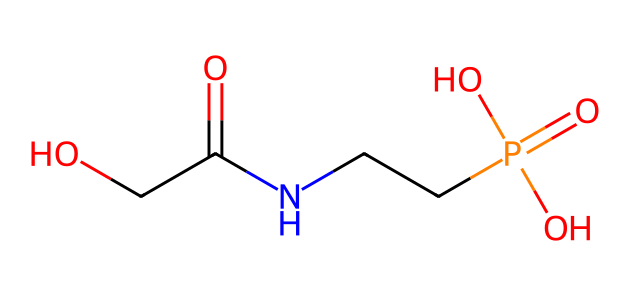What is the molecular formula of glyphosate? To determine the molecular formula, count the different atoms present in the SMILES: there are 3 carbon atoms (C), 8 hydrogen atoms (H), 1 nitrogen atom (N), and 4 oxygen atoms (O). Thus, the molecular formula is C3H8N1O4.
Answer: C3H8N1O4 How many oxygen atoms are in glyphosate? From the SMILES representation, we can see there are 4 oxygen (O) symbols. Counting the total number of oxygen atoms gives us the answer.
Answer: 4 What type of functional group is present in glyphosate? Looking at the structure, the presence of the -COOH (carboxylic acid) and -PO3 (phosphate) groups indicates that glyphosate contains a carboxylic acid and phosphate functional group.
Answer: carboxylic acid and phosphate Which atom in glyphosate is likely responsible for its herbicidal activity? The nitrogen (N) atom in the structure suggests it plays a significant role in glyphosate's mechanism of action, as many herbicides target metabolic pathways involving nitrogen.
Answer: nitrogen What is the total number of carbon-carbon bonds in glyphosate? By examining the structure through the SMILES, we observe that there are no C-C single or double bonds present directly. Since the carbon atoms are connected via other atoms (like nitrogen or oxygen), the total number of carbon-carbon bonds is zero.
Answer: 0 How many functional groups can be identified in glyphosate? By analyzing the structure, we identify two major functional groups: a carboxylic acid (-COOH) and a phosphate group (-PO4). Counting these gives us the total.
Answer: 2 